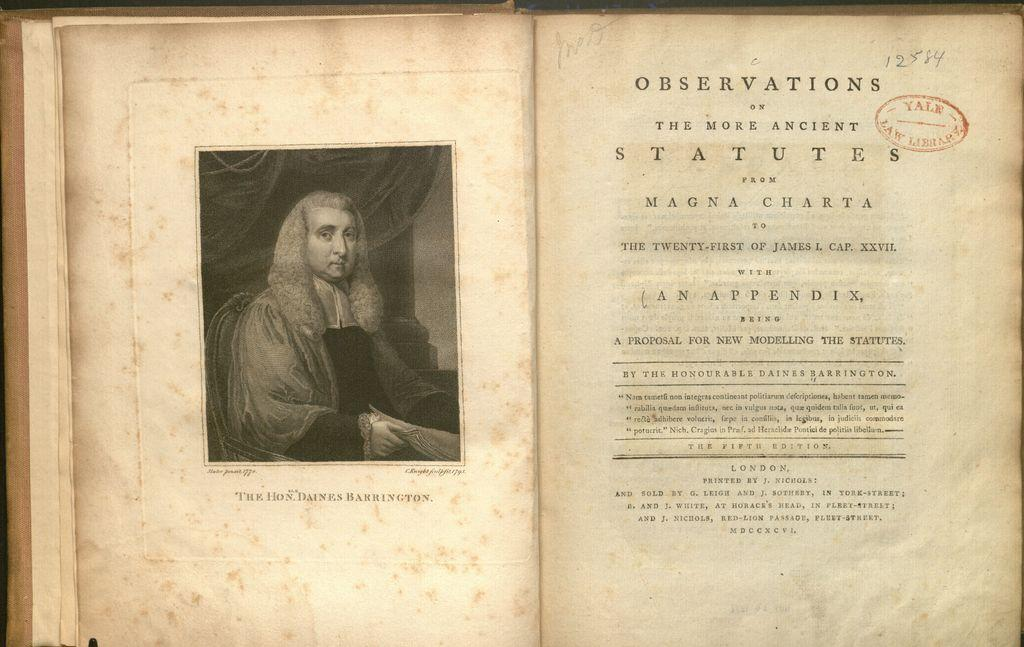<image>
Offer a succinct explanation of the picture presented. An old copy of Observations of the More Ancient Statutes is open to the title page. 